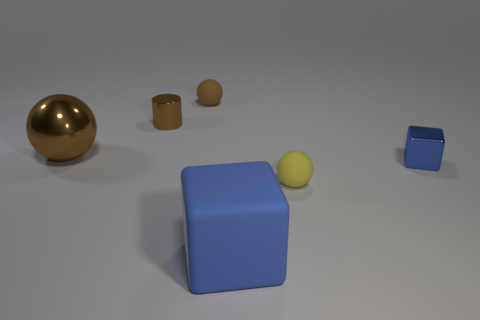What is the color of the tiny metal cube?
Your response must be concise. Blue. The other sphere that is the same size as the brown matte ball is what color?
Make the answer very short. Yellow. There is a shiny object in front of the big brown metal object; is it the same shape as the big blue matte object?
Your response must be concise. Yes. The tiny rubber sphere to the right of the rubber ball behind the metal thing in front of the big metallic thing is what color?
Your answer should be very brief. Yellow. Are any metal things visible?
Your answer should be very brief. Yes. What number of other objects are the same size as the yellow rubber ball?
Your response must be concise. 3. There is a big rubber thing; is it the same color as the small sphere behind the tiny metallic cube?
Give a very brief answer. No. What number of things are either small matte things or small brown metal cylinders?
Give a very brief answer. 3. Is there any other thing of the same color as the cylinder?
Provide a short and direct response. Yes. Is the yellow object made of the same material as the blue object in front of the small blue shiny object?
Provide a succinct answer. Yes. 